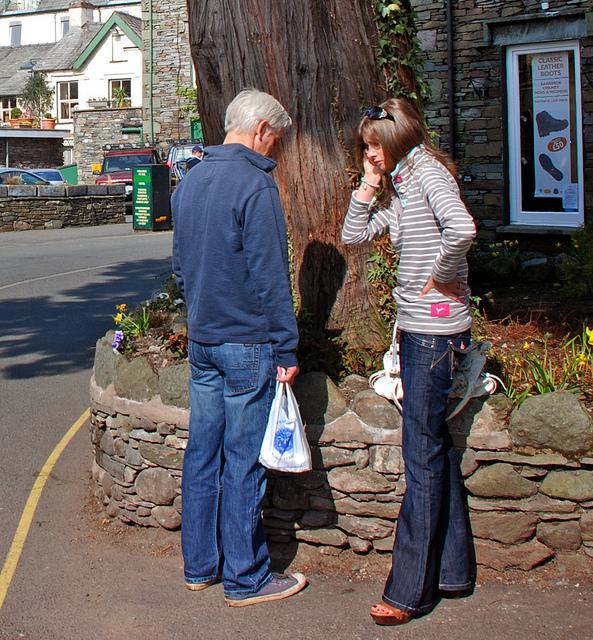Is the lady upset?
Concise answer only. Yes. What ethnicity do the people appear to be?
Write a very short answer. White. Is it sunny?
Give a very brief answer. Yes. What type of flowers are in the picture?
Short answer required. Tulips. Are they discussing a serious issue?
Write a very short answer. Yes. What is the person wearing around their waist?
Concise answer only. Belt. Where are three brown pots?
Be succinct. Nowhere. 